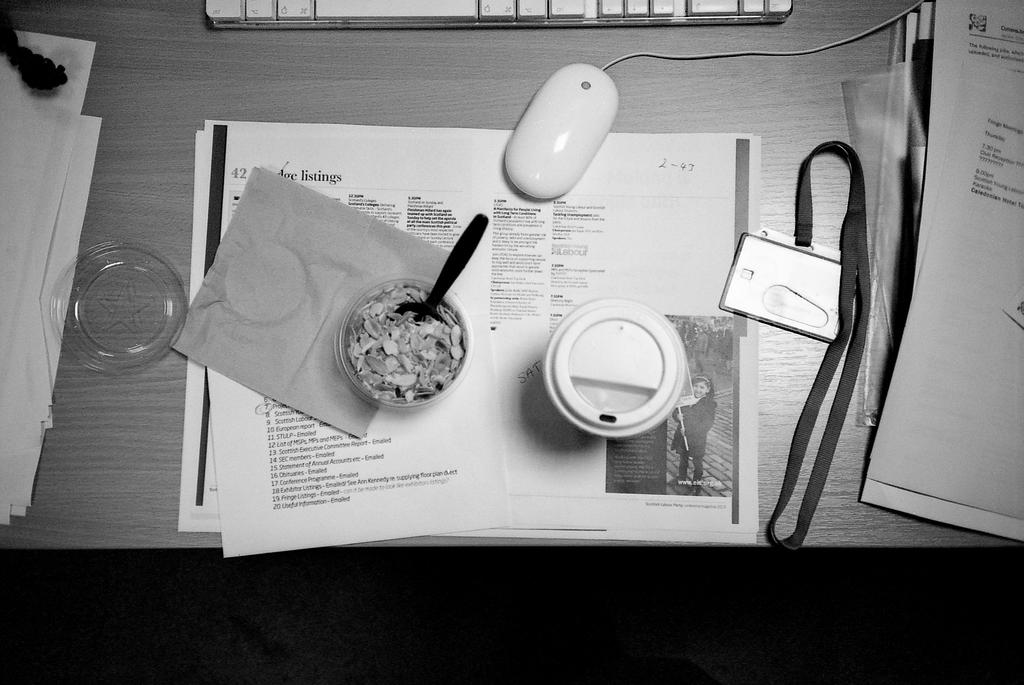What is the main piece of furniture in the image? There is a table in the image. What is located on the table? There is a mouse, a keyboard, papers, an ID card with a tag, a bowl with a food item, and a spoon on the table. What type of food item is in the bowl? The bowl contains a food item, but the specific type is not mentioned in the facts. What is the ID card attached to? The ID card has a tag attached to it. How much dirt is visible on the mouse in the image? There is no mention of dirt on the mouse in the image, so it cannot be determined from the facts. What is the mouse feeling in the image? The facts do not provide information about the emotions of the mouse, so it cannot be determined from the image. 